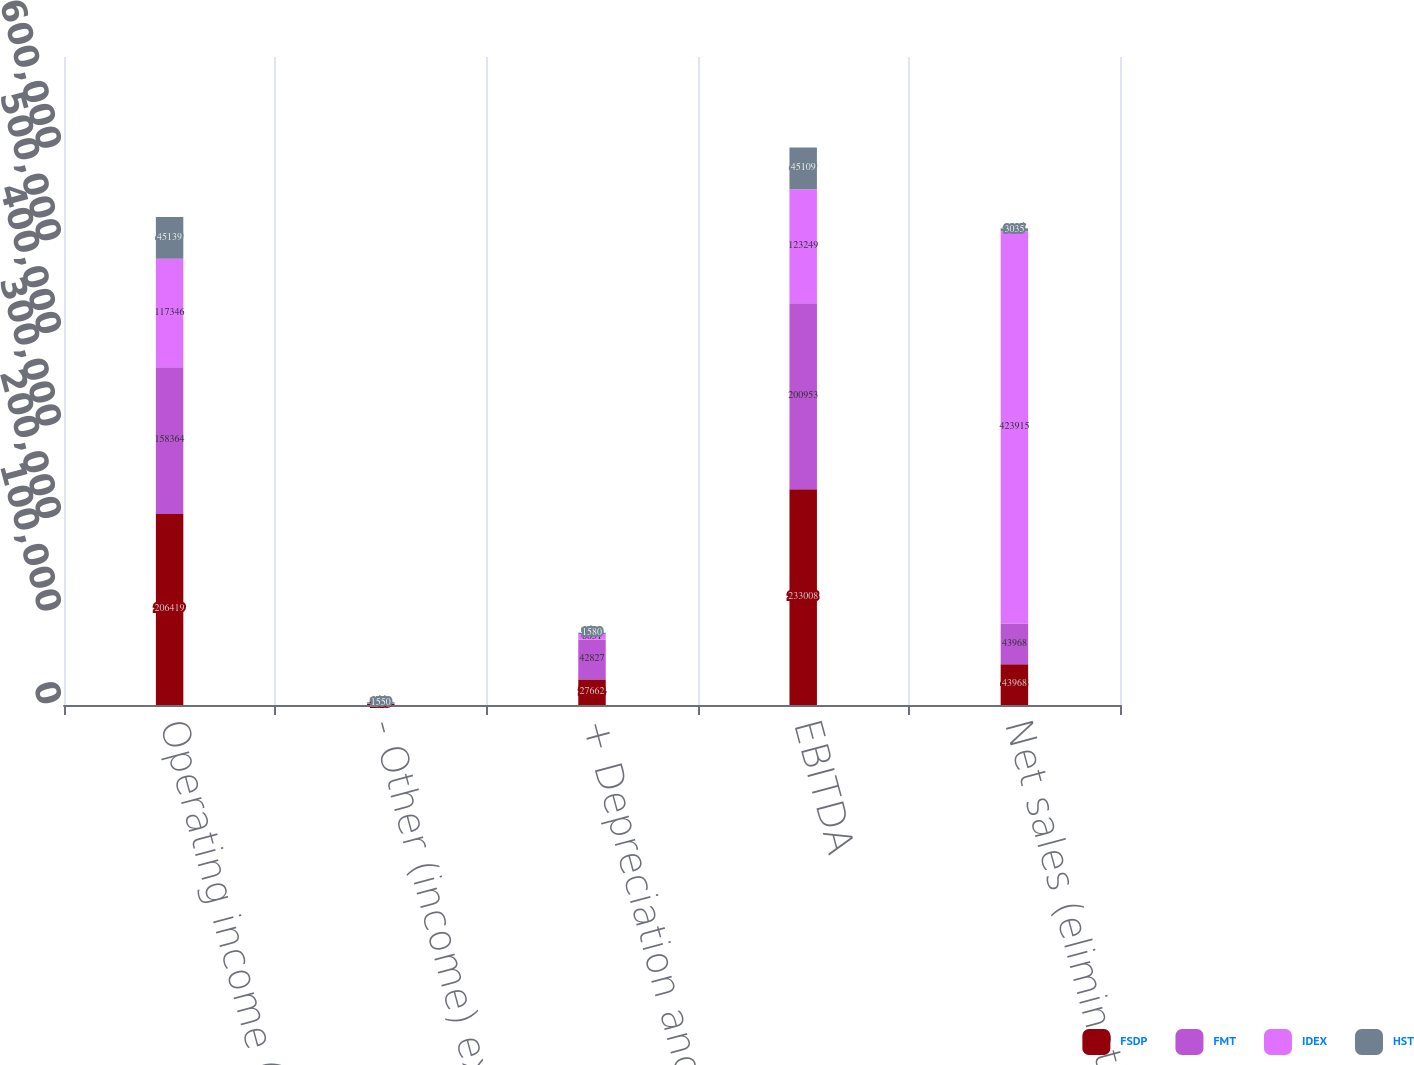Convert chart. <chart><loc_0><loc_0><loc_500><loc_500><stacked_bar_chart><ecel><fcel>Operating income (loss)<fcel>- Other (income) expense - net<fcel>+ Depreciation and<fcel>EBITDA<fcel>Net sales (eliminations)<nl><fcel>FSDP<fcel>206419<fcel>1073<fcel>27662<fcel>233008<fcel>43968<nl><fcel>FMT<fcel>158364<fcel>238<fcel>42827<fcel>200953<fcel>43968<nl><fcel>IDEX<fcel>117346<fcel>148<fcel>6051<fcel>123249<fcel>423915<nl><fcel>HST<fcel>45139<fcel>1550<fcel>1580<fcel>45109<fcel>3035<nl></chart> 